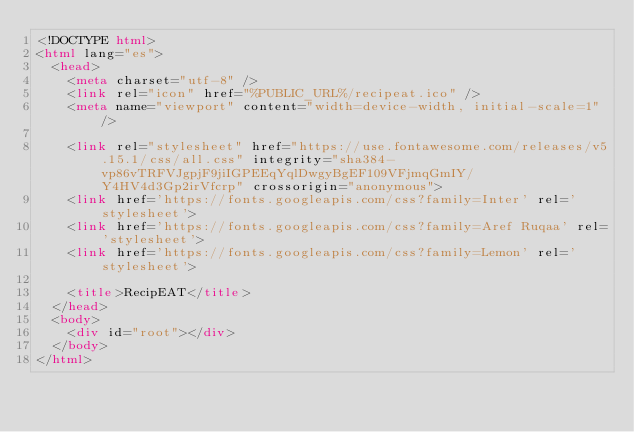Convert code to text. <code><loc_0><loc_0><loc_500><loc_500><_HTML_><!DOCTYPE html>
<html lang="es">
  <head>
    <meta charset="utf-8" />
    <link rel="icon" href="%PUBLIC_URL%/recipeat.ico" />
    <meta name="viewport" content="width=device-width, initial-scale=1" />

    <link rel="stylesheet" href="https://use.fontawesome.com/releases/v5.15.1/css/all.css" integrity="sha384-vp86vTRFVJgpjF9jiIGPEEqYqlDwgyBgEF109VFjmqGmIY/Y4HV4d3Gp2irVfcrp" crossorigin="anonymous">
    <link href='https://fonts.googleapis.com/css?family=Inter' rel='stylesheet'>
    <link href='https://fonts.googleapis.com/css?family=Aref Ruqaa' rel='stylesheet'>
    <link href='https://fonts.googleapis.com/css?family=Lemon' rel='stylesheet'>

    <title>RecipEAT</title>
  </head>
  <body>
    <div id="root"></div>
  </body>
</html>
</code> 